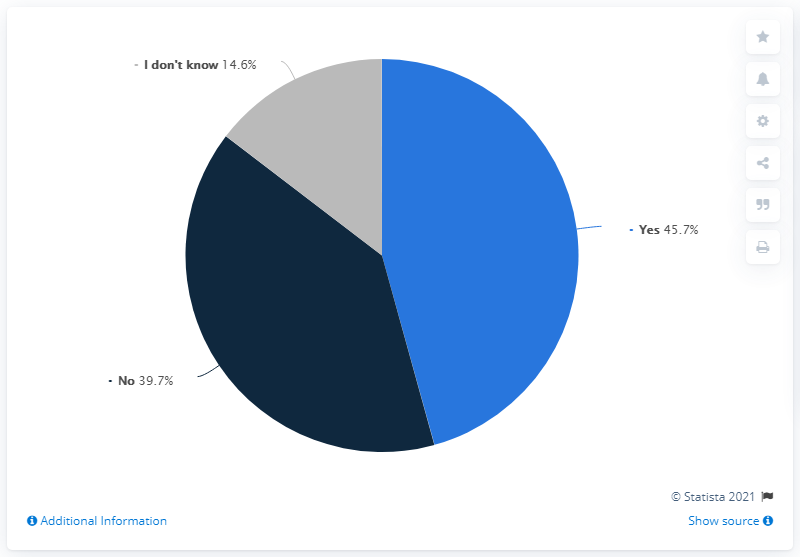Highlight a few significant elements in this photo. The average opinion percent is subtracted from the median opinion percent, resulting in a value of 6.36. The color segment that does not represent either "yes" or "no" is gray. 